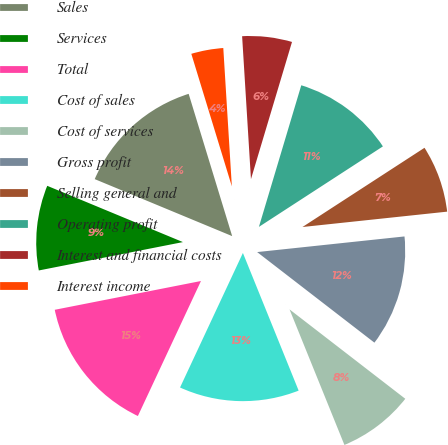Convert chart to OTSL. <chart><loc_0><loc_0><loc_500><loc_500><pie_chart><fcel>Sales<fcel>Services<fcel>Total<fcel>Cost of sales<fcel>Cost of services<fcel>Gross profit<fcel>Selling general and<fcel>Operating profit<fcel>Interest and financial costs<fcel>Interest income<nl><fcel>14.02%<fcel>9.35%<fcel>14.95%<fcel>13.08%<fcel>8.41%<fcel>12.15%<fcel>7.48%<fcel>11.21%<fcel>5.61%<fcel>3.74%<nl></chart> 